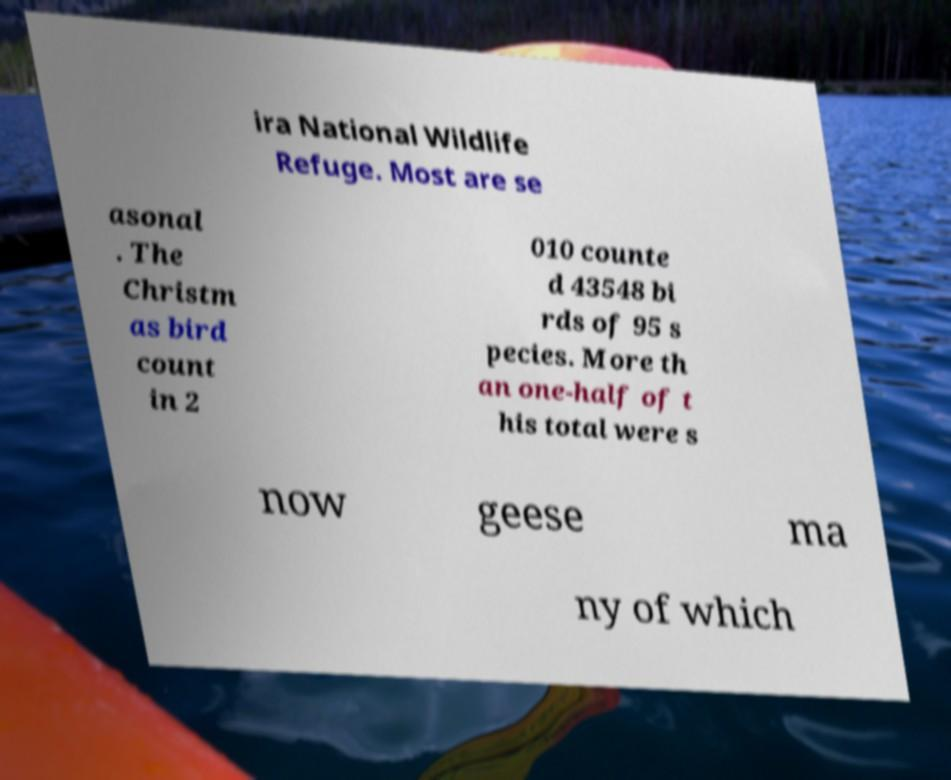Can you read and provide the text displayed in the image?This photo seems to have some interesting text. Can you extract and type it out for me? ira National Wildlife Refuge. Most are se asonal . The Christm as bird count in 2 010 counte d 43548 bi rds of 95 s pecies. More th an one-half of t his total were s now geese ma ny of which 